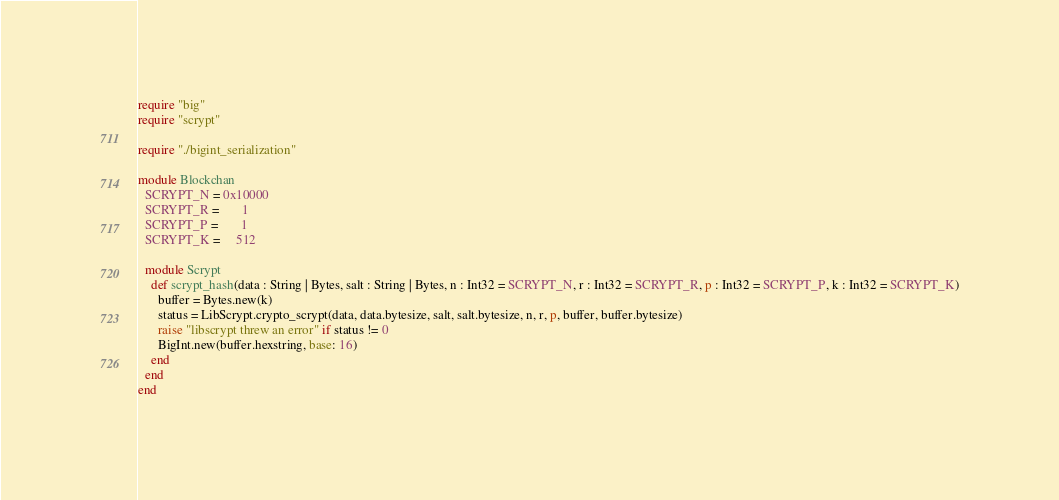Convert code to text. <code><loc_0><loc_0><loc_500><loc_500><_Crystal_>require "big"
require "scrypt"

require "./bigint_serialization"

module Blockchan
  SCRYPT_N = 0x10000
  SCRYPT_R =       1
  SCRYPT_P =       1
  SCRYPT_K =     512

  module Scrypt
    def scrypt_hash(data : String | Bytes, salt : String | Bytes, n : Int32 = SCRYPT_N, r : Int32 = SCRYPT_R, p : Int32 = SCRYPT_P, k : Int32 = SCRYPT_K)
      buffer = Bytes.new(k)
      status = LibScrypt.crypto_scrypt(data, data.bytesize, salt, salt.bytesize, n, r, p, buffer, buffer.bytesize)
      raise "libscrypt threw an error" if status != 0
      BigInt.new(buffer.hexstring, base: 16)
    end
  end
end
</code> 